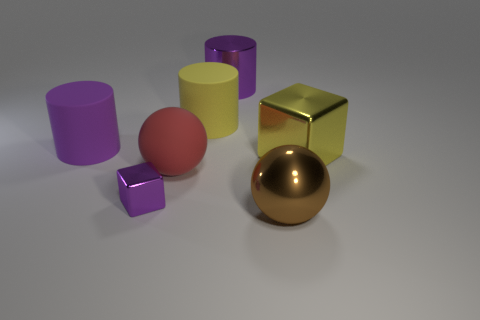Add 2 yellow rubber cylinders. How many objects exist? 9 Subtract all cylinders. How many objects are left? 4 Subtract 1 purple blocks. How many objects are left? 6 Subtract all big yellow metallic blocks. Subtract all red matte objects. How many objects are left? 5 Add 2 large yellow cylinders. How many large yellow cylinders are left? 3 Add 7 blue balls. How many blue balls exist? 7 